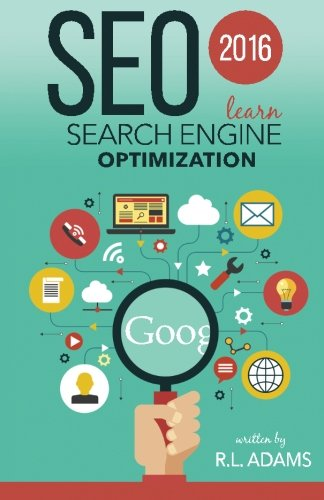Who is the author of this book? The author of 'SEO 2016: Learn Search Engine Optimization' is R L Adams, an author noted for his expertise in digital marketing and SEO strategies. 